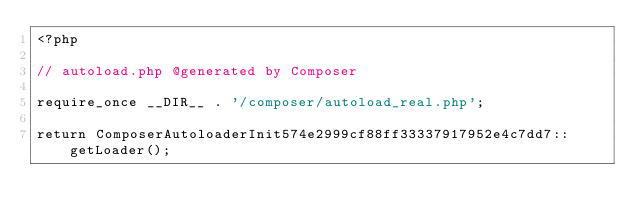<code> <loc_0><loc_0><loc_500><loc_500><_PHP_><?php

// autoload.php @generated by Composer

require_once __DIR__ . '/composer/autoload_real.php';

return ComposerAutoloaderInit574e2999cf88ff33337917952e4c7dd7::getLoader();
</code> 